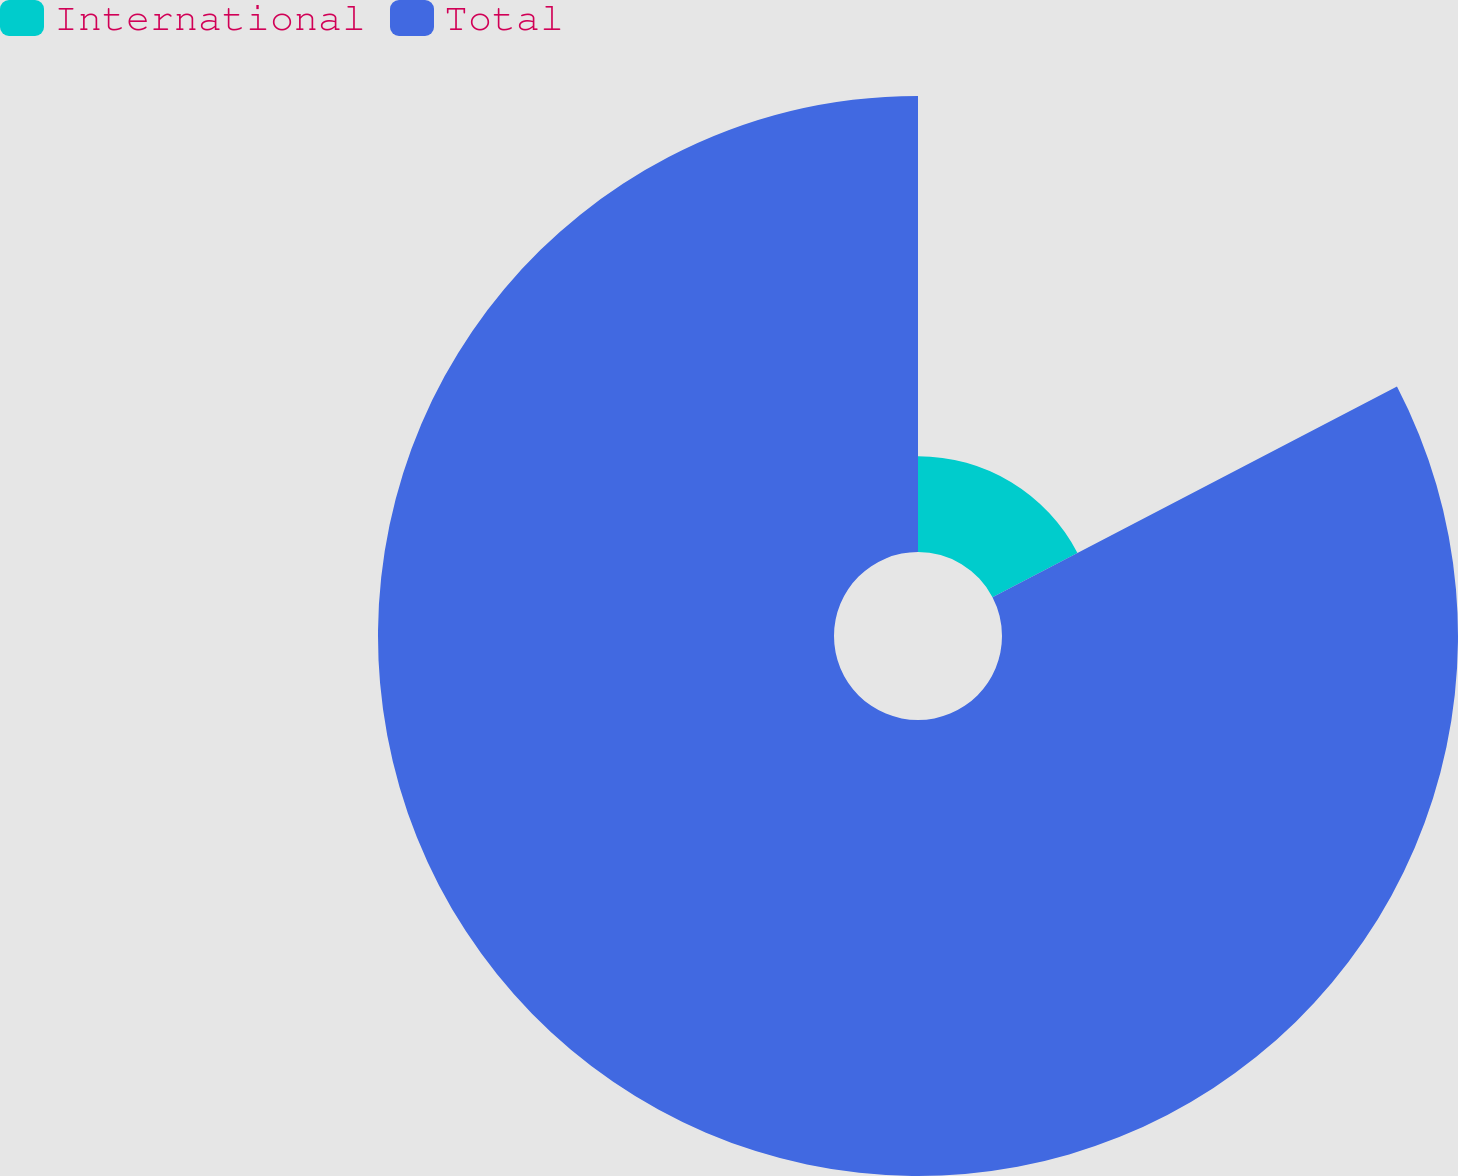Convert chart to OTSL. <chart><loc_0><loc_0><loc_500><loc_500><pie_chart><fcel>International<fcel>Total<nl><fcel>17.36%<fcel>82.64%<nl></chart> 